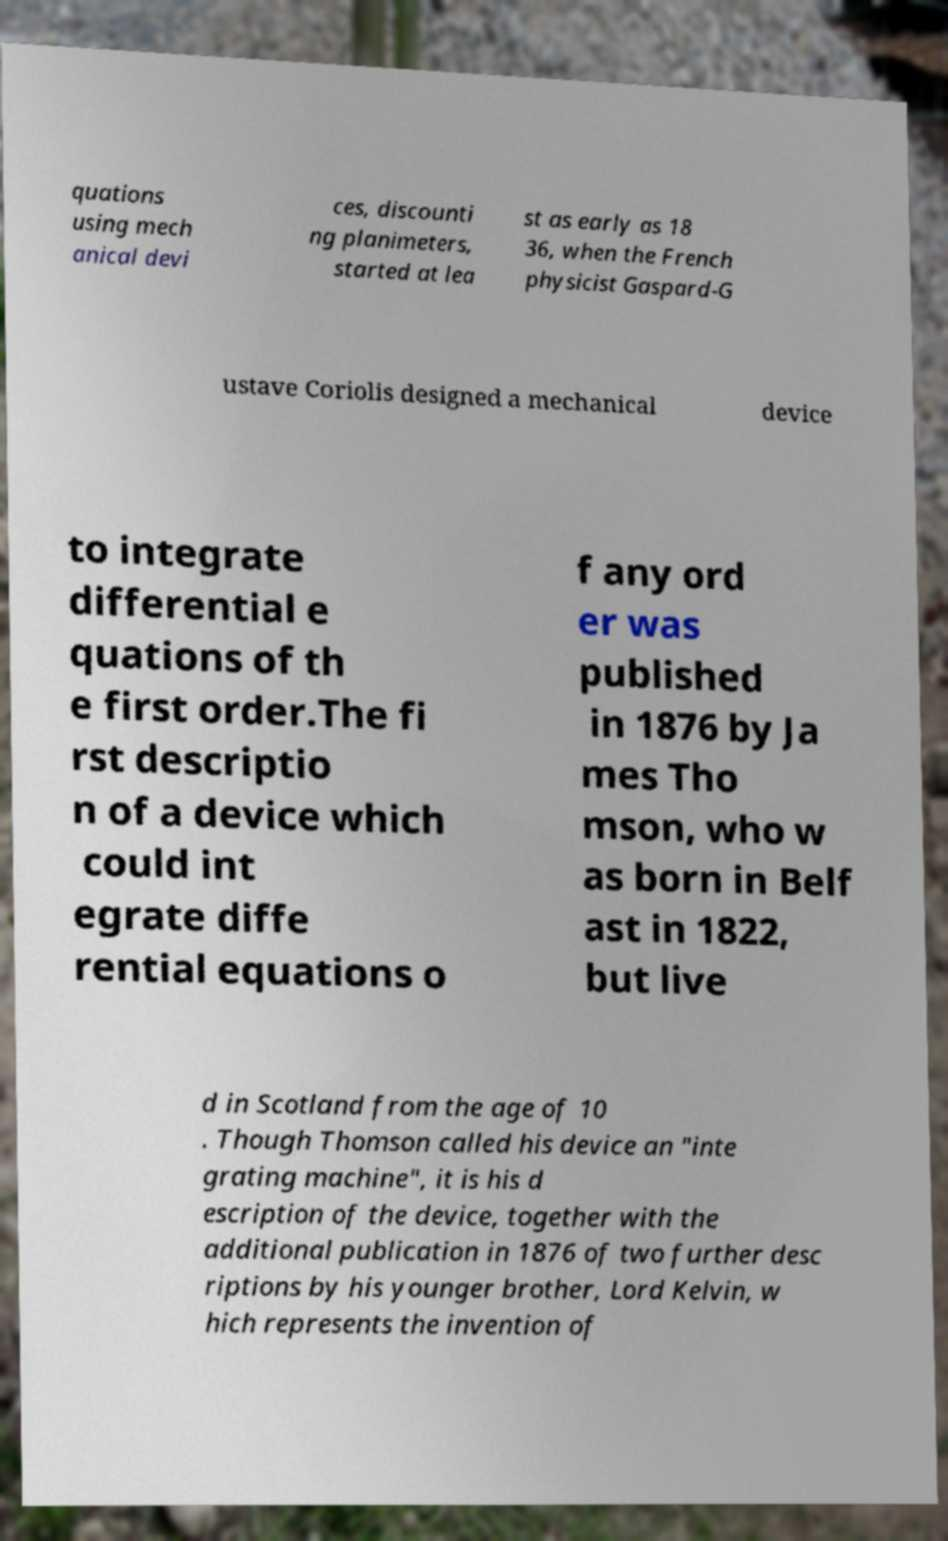Can you accurately transcribe the text from the provided image for me? quations using mech anical devi ces, discounti ng planimeters, started at lea st as early as 18 36, when the French physicist Gaspard-G ustave Coriolis designed a mechanical device to integrate differential e quations of th e first order.The fi rst descriptio n of a device which could int egrate diffe rential equations o f any ord er was published in 1876 by Ja mes Tho mson, who w as born in Belf ast in 1822, but live d in Scotland from the age of 10 . Though Thomson called his device an "inte grating machine", it is his d escription of the device, together with the additional publication in 1876 of two further desc riptions by his younger brother, Lord Kelvin, w hich represents the invention of 